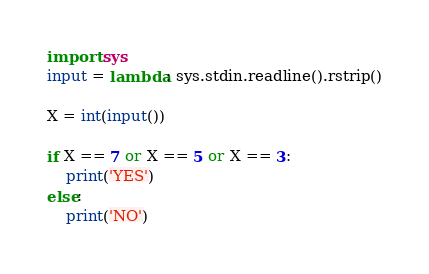<code> <loc_0><loc_0><loc_500><loc_500><_Python_>import sys
input = lambda: sys.stdin.readline().rstrip()

X = int(input())

if X == 7 or X == 5 or X == 3:
    print('YES')
else:
    print('NO') </code> 